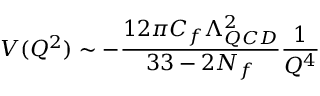<formula> <loc_0><loc_0><loc_500><loc_500>V ( Q ^ { 2 } ) \sim - { \frac { 1 2 \pi C _ { f } \Lambda _ { Q C D } ^ { 2 } } { 3 3 - 2 N _ { f } } } { \frac { 1 } { Q ^ { 4 } } }</formula> 